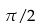Convert formula to latex. <formula><loc_0><loc_0><loc_500><loc_500>\pi / 2</formula> 